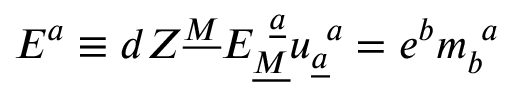Convert formula to latex. <formula><loc_0><loc_0><loc_500><loc_500>E ^ { a } \equiv d Z ^ { \underline { M } } E _ { \underline { M } } ^ { \underline { a } } u _ { \underline { a } } ^ { a } = e ^ { b } m _ { b } ^ { a }</formula> 